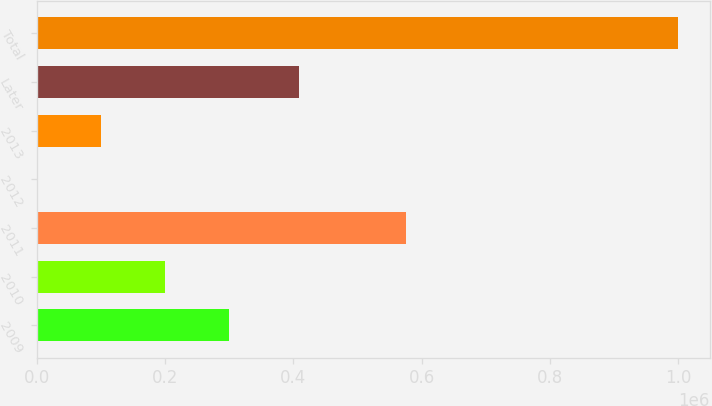Convert chart to OTSL. <chart><loc_0><loc_0><loc_500><loc_500><bar_chart><fcel>2009<fcel>2010<fcel>2011<fcel>2012<fcel>2013<fcel>Later<fcel>Total<nl><fcel>300500<fcel>200662<fcel>576265<fcel>985<fcel>100823<fcel>409295<fcel>999369<nl></chart> 